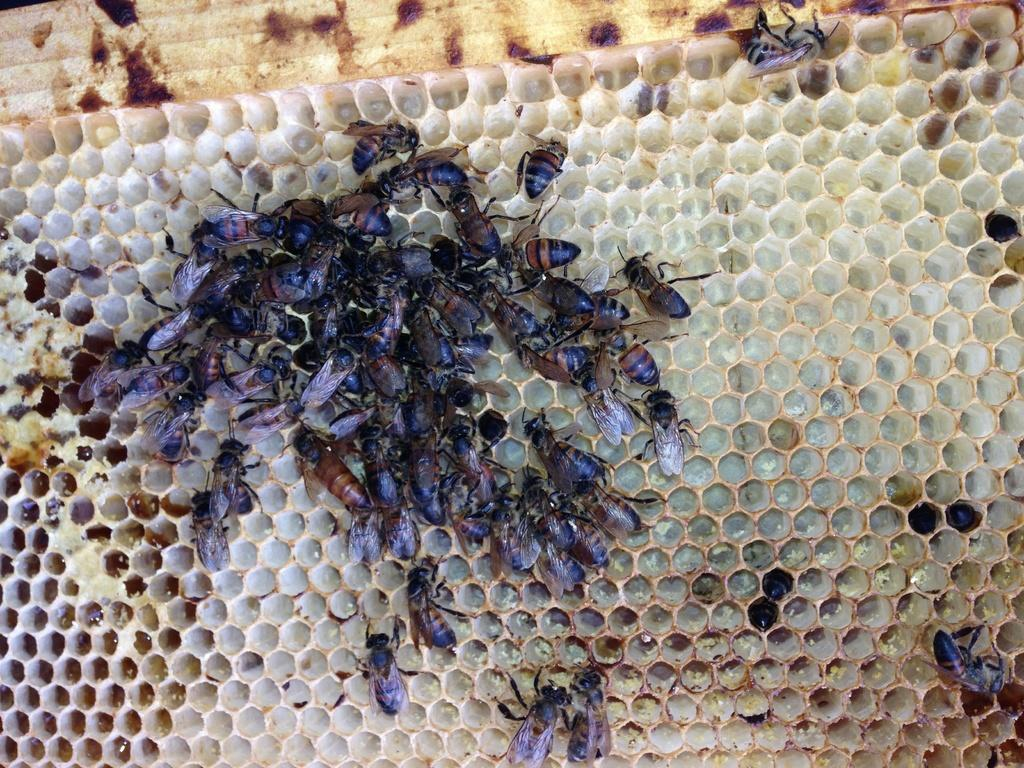What type of insects are present in the image? There are honeybees in the image. What structure is associated with honeybees and visible in the image? There is a honeycomb in the image. How many beads are present in the image? There are no beads present in the image. What is the distance between the honeybees in the image? The distance between the honeybees cannot be determined from the image alone, as it only provides a static snapshot. What type of prose can be seen written on the honeycomb in the image? There is no prose written on the honeycomb in the image; it is a natural structure created by honeybees. 